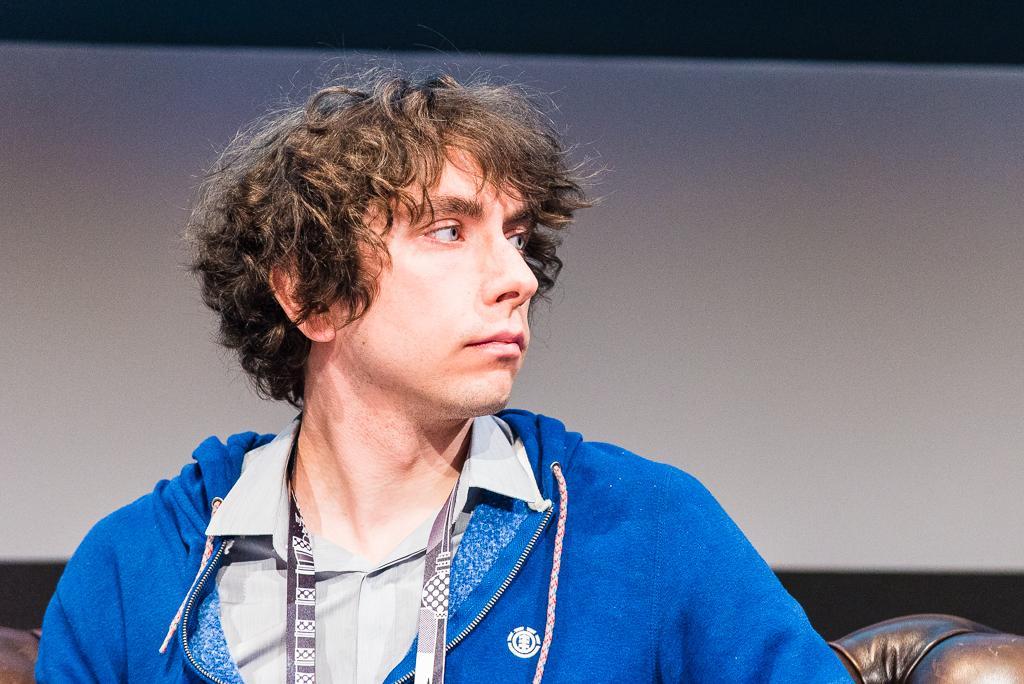In one or two sentences, can you explain what this image depicts? In the picture we can see a man sitting on a black color sofa, chair and he is wearing a blue color hoodie and gray color T-shirt and a tag and he is looking for a side and in the background we can see a wall which is white in color. 